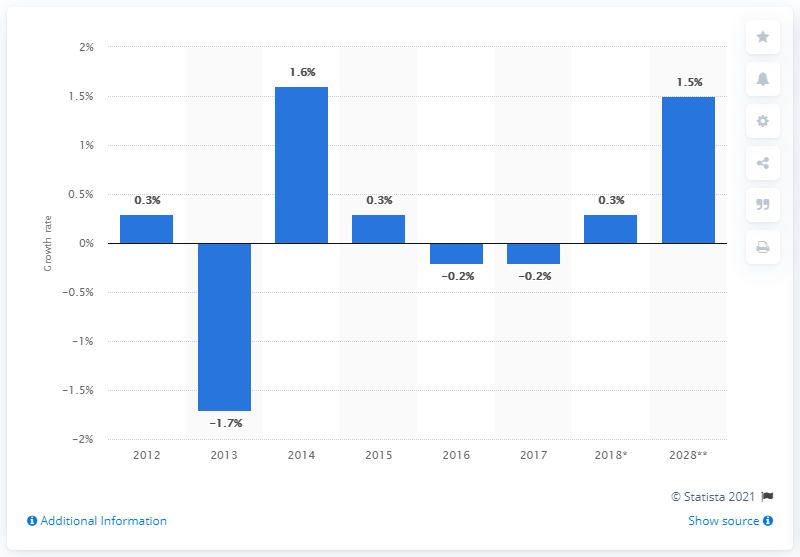Identify some key points in this picture. The growth rate of government spending in the travel industry in 2018 was 0.3%. 